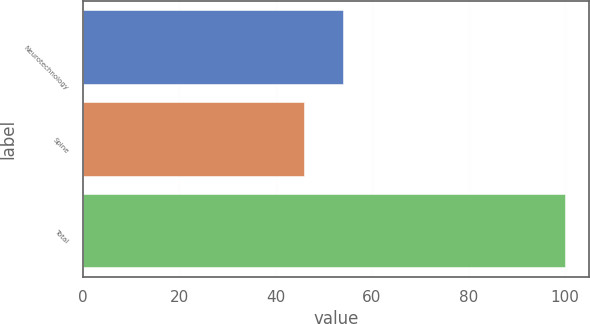Convert chart. <chart><loc_0><loc_0><loc_500><loc_500><bar_chart><fcel>Neurotechnology<fcel>Spine<fcel>Total<nl><fcel>54<fcel>46<fcel>100<nl></chart> 